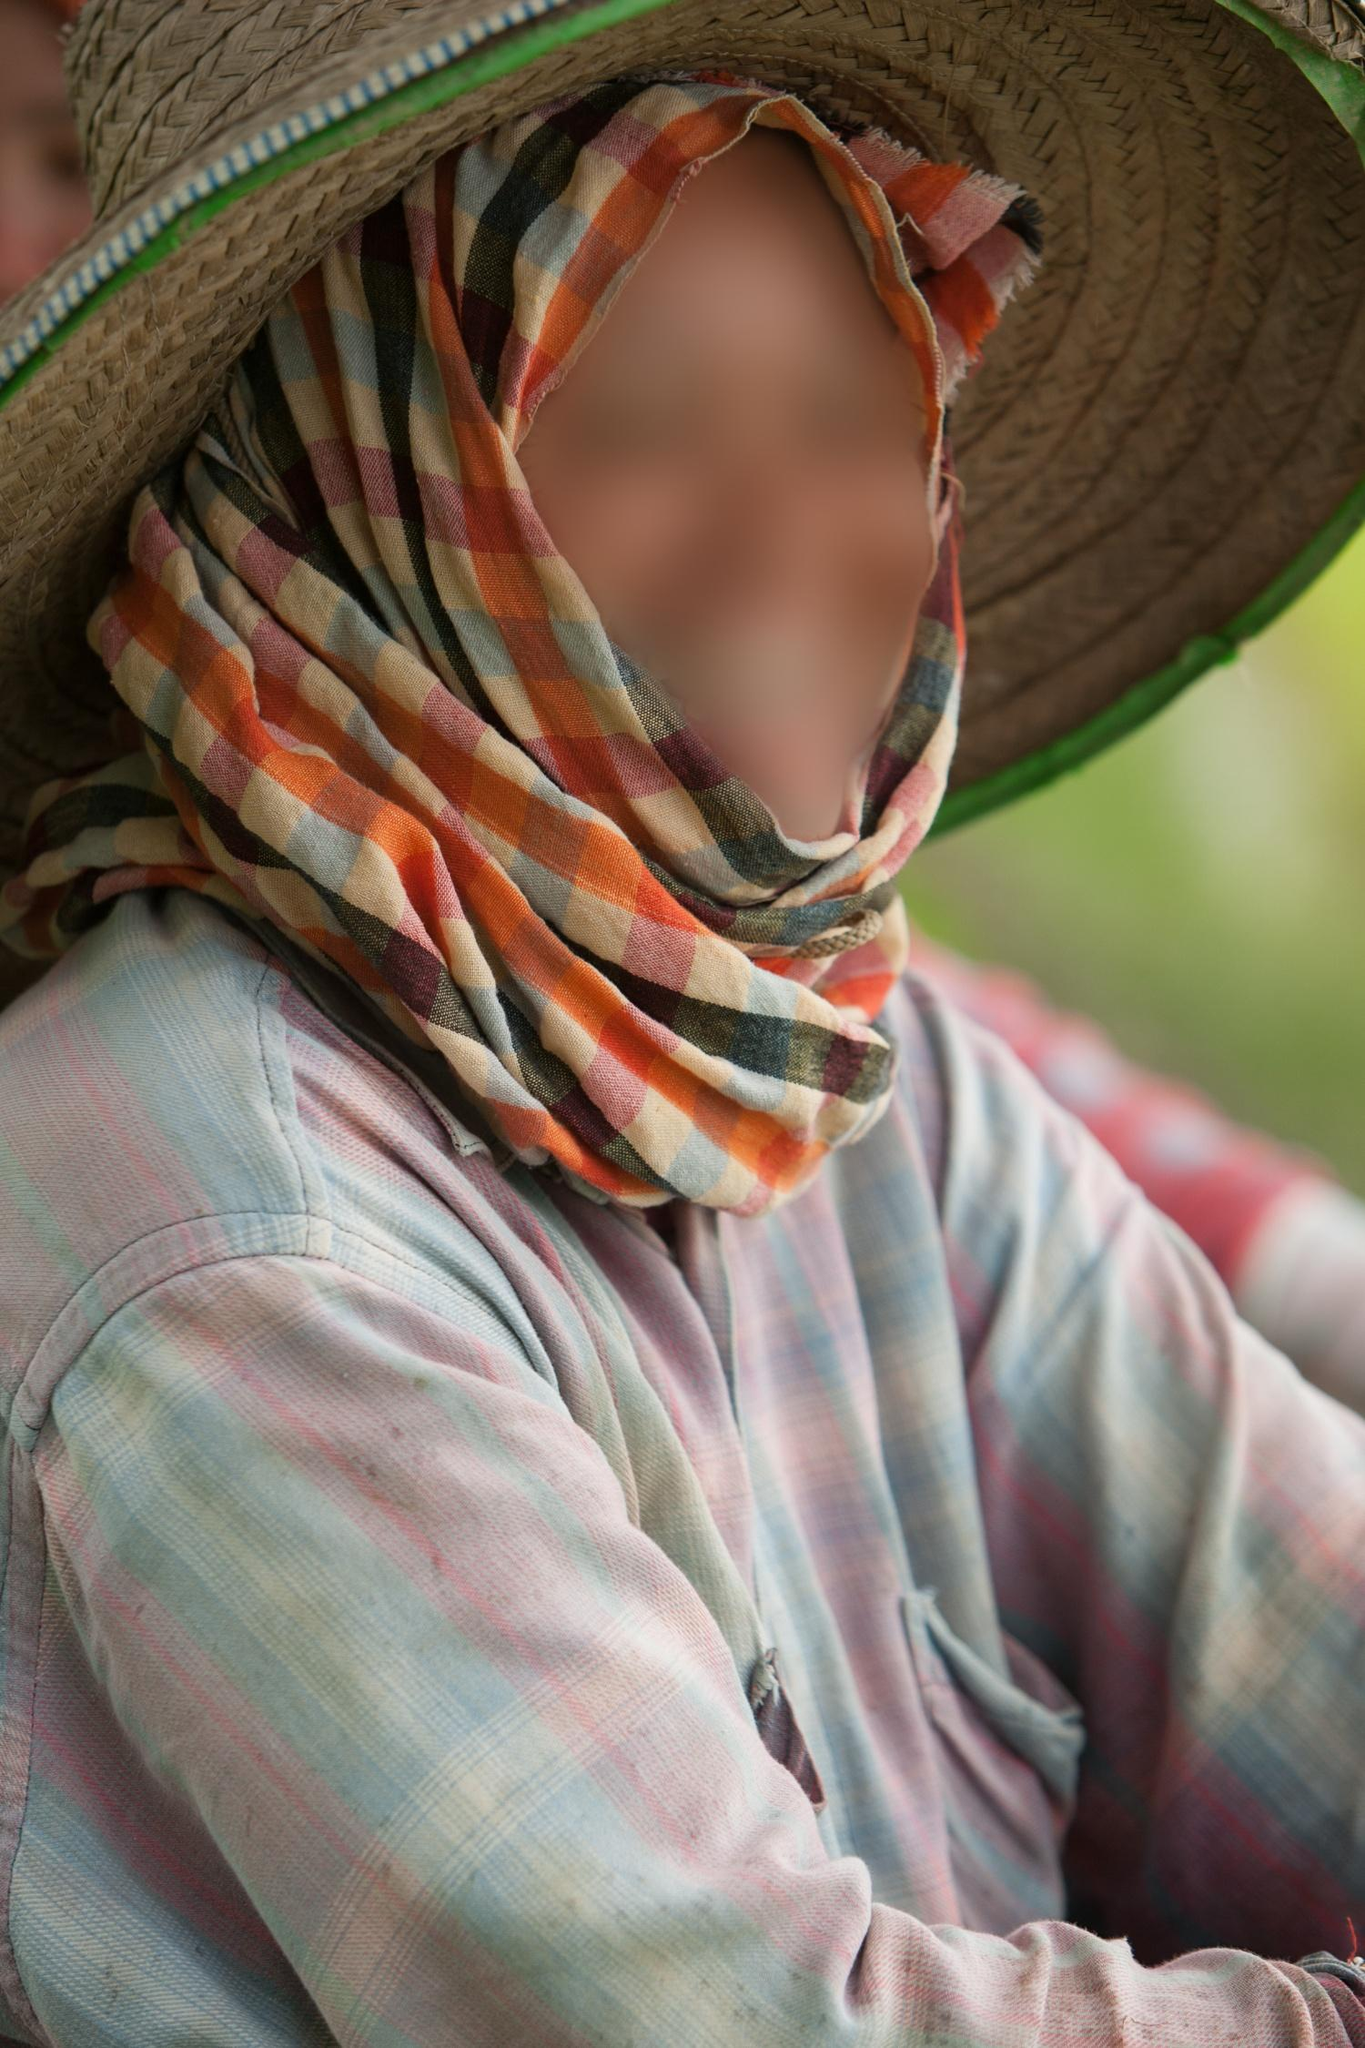What's happening in the scene?
 The image captures a person in an outdoor setting, their identity concealed by a straw hat and a vibrant scarf. The hat, a classic symbol of rural life, casts a shadow over the person's face, adding an air of mystery. The scarf, adorned with a riot of colors, wraps around their face, leaving only their eyes visible. These eyes, full of life, provide a stark contrast to the otherwise hidden face.

The person is dressed in a plaid shirt, a blend of pink and blue checks, which adds a casual and relaxed vibe to the image. The shirt, slightly loose, billows out, suggesting a light breeze might be playing across the scene.

The background is a blur of green, hinting at a lush, verdant landscape beyond the immediate focus of the image. The greenery suggests that the photo might have been taken in a rural or semi-rural location, perhaps a farm or a park.

The perspective of the image is such that the person takes up the majority of the frame, drawing the viewer's attention immediately. The blurred background puts the focus squarely on the person, making them the undeniable subject of the image.

As for the landmark information "sa_10078", I'm afraid I couldn't find any relevant information about it from my current resources. It might be a specific code or identifier that needs more context to understand. If you have more details or context about this, I'd be glad to help further! 